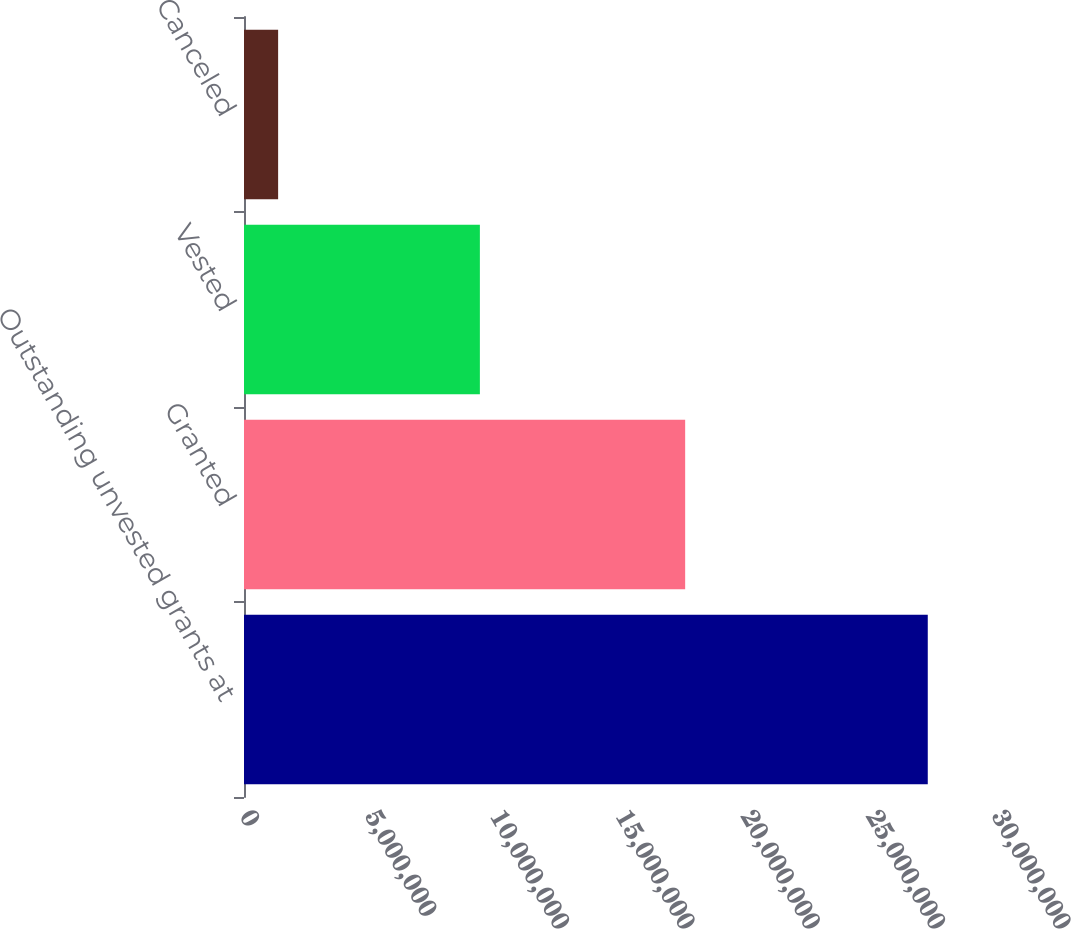Convert chart to OTSL. <chart><loc_0><loc_0><loc_500><loc_500><bar_chart><fcel>Outstanding unvested grants at<fcel>Granted<fcel>Vested<fcel>Canceled<nl><fcel>2.72781e+07<fcel>1.75997e+07<fcel>9.40984e+06<fcel>1.36136e+06<nl></chart> 